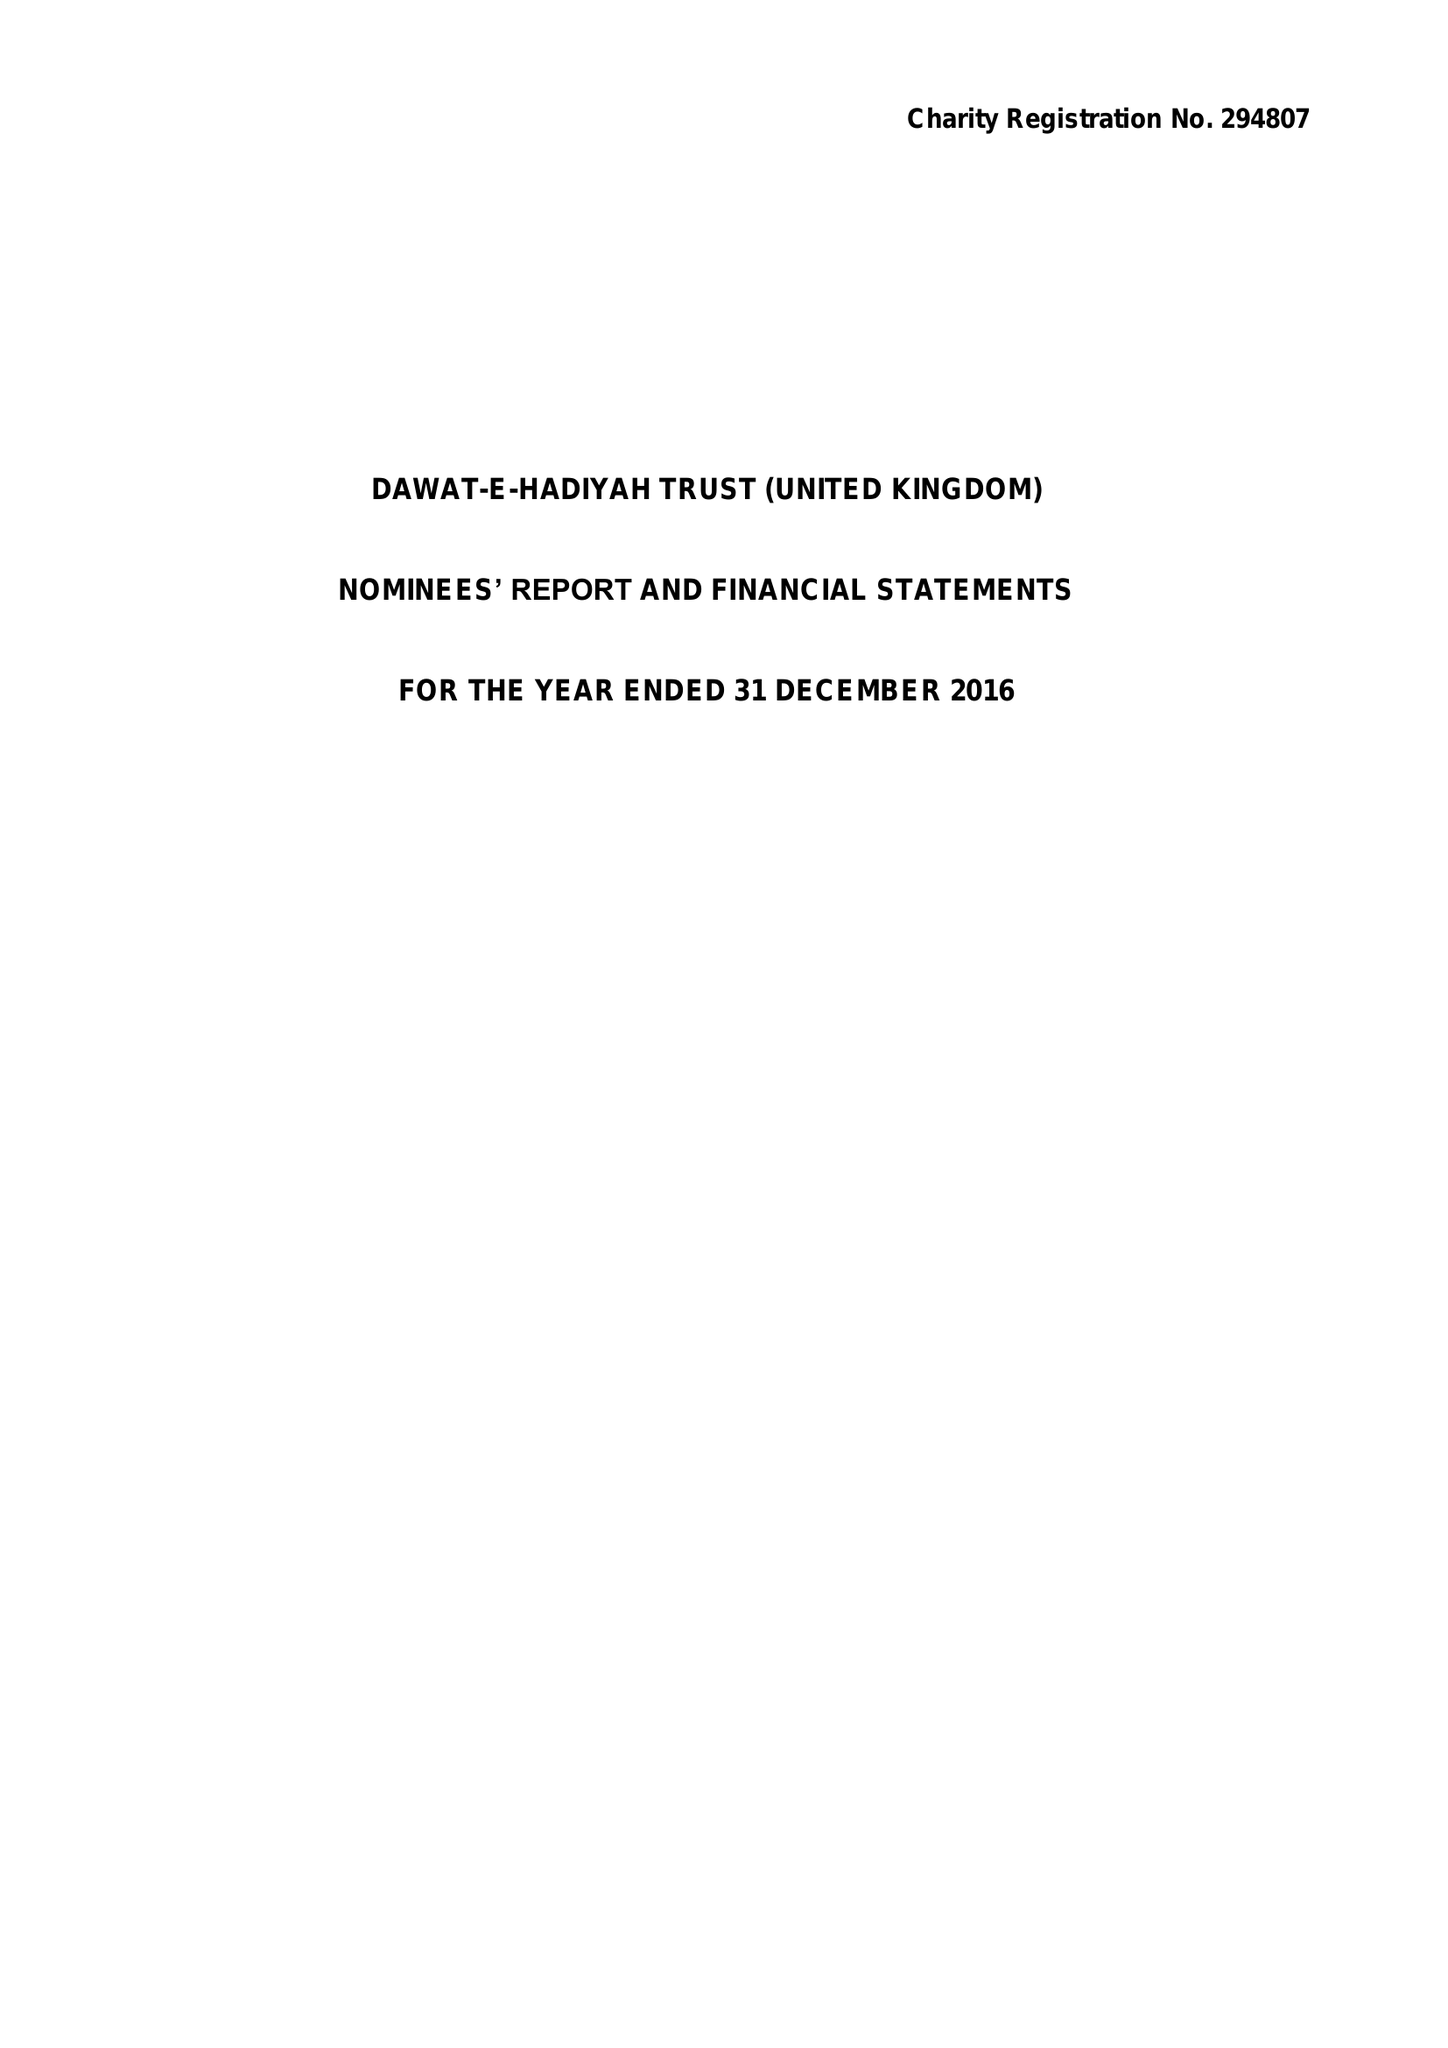What is the value for the charity_number?
Answer the question using a single word or phrase. 294807 